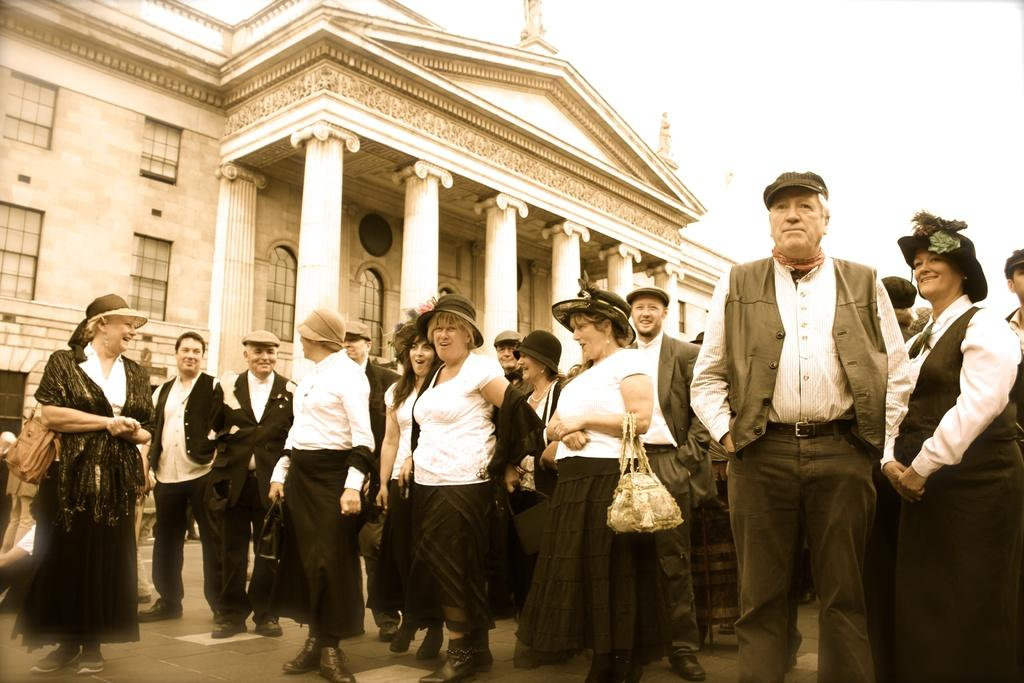What is happening in the middle of the image? There are people standing in the middle of the image. What can be seen behind the people? There is a building visible behind the people. What part of the sky is visible in the image? The sky is visible in the top right corner of the image. What type of toothpaste is being used to attack the building in the image? There is no toothpaste or attack present in the image; it features people standing in front of a building with the sky visible in the top right corner. 